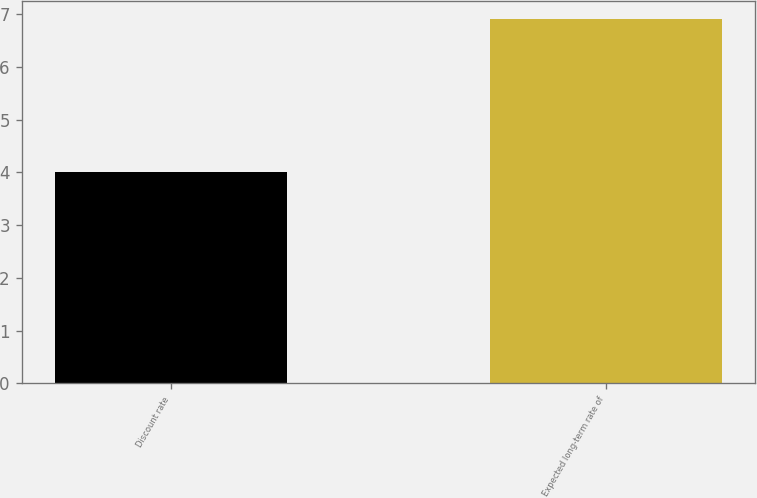Convert chart. <chart><loc_0><loc_0><loc_500><loc_500><bar_chart><fcel>Discount rate<fcel>Expected long-term rate of<nl><fcel>4<fcel>6.9<nl></chart> 